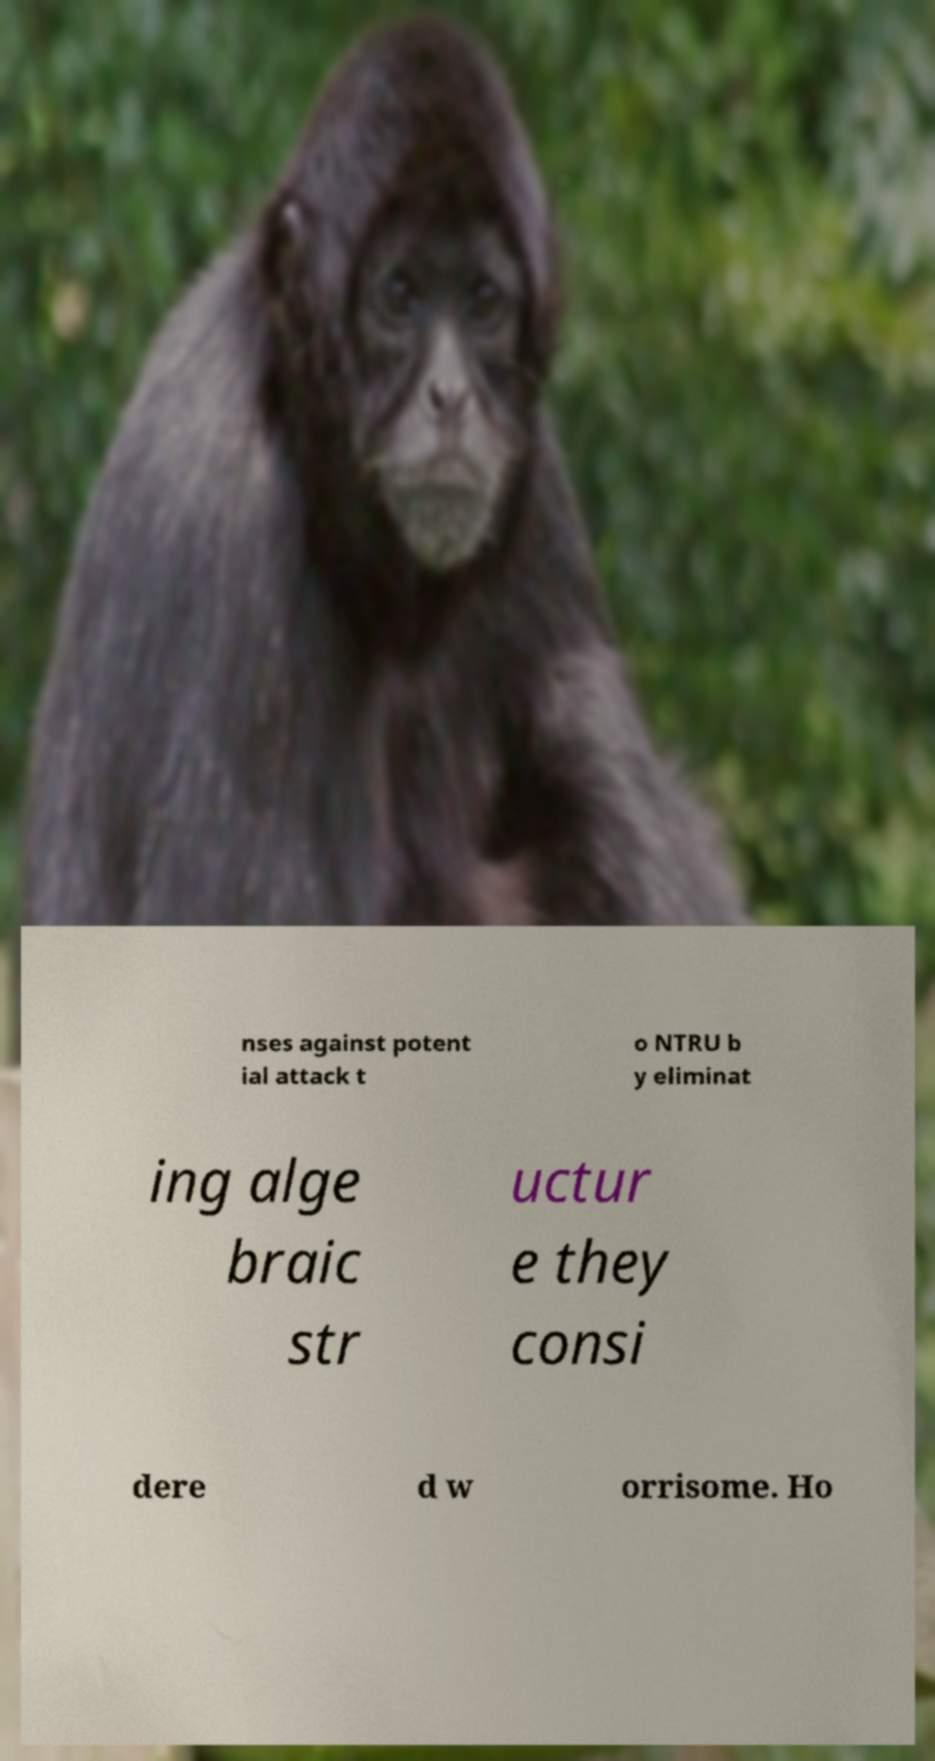I need the written content from this picture converted into text. Can you do that? nses against potent ial attack t o NTRU b y eliminat ing alge braic str uctur e they consi dere d w orrisome. Ho 